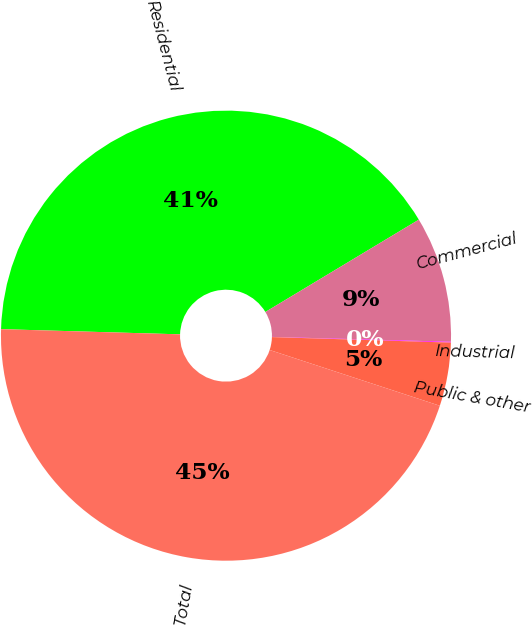Convert chart. <chart><loc_0><loc_0><loc_500><loc_500><pie_chart><fcel>Residential<fcel>Commercial<fcel>Industrial<fcel>Public & other<fcel>Total<nl><fcel>40.92%<fcel>9.05%<fcel>0.06%<fcel>4.55%<fcel>45.42%<nl></chart> 